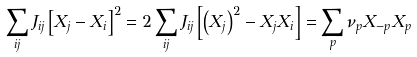Convert formula to latex. <formula><loc_0><loc_0><loc_500><loc_500>\sum _ { i j } J _ { i j } \left [ X _ { j } - X _ { i } \right ] ^ { 2 } = 2 \sum _ { i j } J _ { i j } \left [ \left ( X _ { j } \right ) ^ { 2 } - X _ { j } X _ { i } \right ] = \sum _ { p } \nu _ { p } X _ { - p } X _ { p }</formula> 